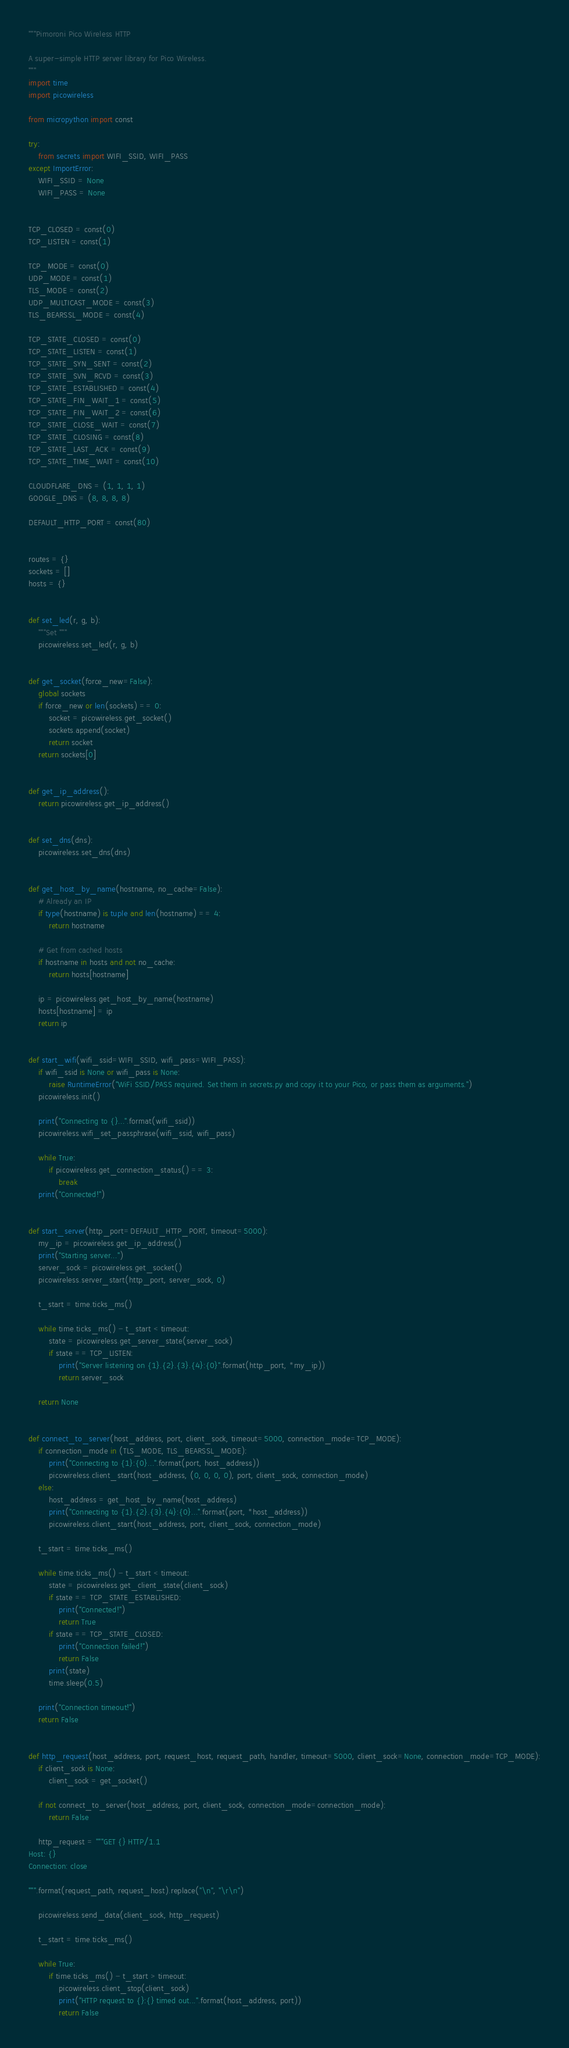Convert code to text. <code><loc_0><loc_0><loc_500><loc_500><_Python_>"""Pimoroni Pico Wireless HTTP

A super-simple HTTP server library for Pico Wireless.
"""
import time
import picowireless

from micropython import const

try:
    from secrets import WIFI_SSID, WIFI_PASS
except ImportError:
    WIFI_SSID = None
    WIFI_PASS = None


TCP_CLOSED = const(0)
TCP_LISTEN = const(1)

TCP_MODE = const(0)
UDP_MODE = const(1)
TLS_MODE = const(2)
UDP_MULTICAST_MODE = const(3)
TLS_BEARSSL_MODE = const(4)

TCP_STATE_CLOSED = const(0)
TCP_STATE_LISTEN = const(1)
TCP_STATE_SYN_SENT = const(2)
TCP_STATE_SVN_RCVD = const(3)
TCP_STATE_ESTABLISHED = const(4)
TCP_STATE_FIN_WAIT_1 = const(5)
TCP_STATE_FIN_WAIT_2 = const(6)
TCP_STATE_CLOSE_WAIT = const(7)
TCP_STATE_CLOSING = const(8)
TCP_STATE_LAST_ACK = const(9)
TCP_STATE_TIME_WAIT = const(10)

CLOUDFLARE_DNS = (1, 1, 1, 1)
GOOGLE_DNS = (8, 8, 8, 8)

DEFAULT_HTTP_PORT = const(80)


routes = {}
sockets = []
hosts = {}


def set_led(r, g, b):
    """Set """
    picowireless.set_led(r, g, b)


def get_socket(force_new=False):
    global sockets
    if force_new or len(sockets) == 0:
        socket = picowireless.get_socket()
        sockets.append(socket)
        return socket
    return sockets[0]


def get_ip_address():
    return picowireless.get_ip_address()


def set_dns(dns):
    picowireless.set_dns(dns)


def get_host_by_name(hostname, no_cache=False):
    # Already an IP
    if type(hostname) is tuple and len(hostname) == 4:
        return hostname

    # Get from cached hosts
    if hostname in hosts and not no_cache:
        return hosts[hostname]

    ip = picowireless.get_host_by_name(hostname)
    hosts[hostname] = ip
    return ip


def start_wifi(wifi_ssid=WIFI_SSID, wifi_pass=WIFI_PASS):
    if wifi_ssid is None or wifi_pass is None:
        raise RuntimeError("WiFi SSID/PASS required. Set them in secrets.py and copy it to your Pico, or pass them as arguments.")
    picowireless.init()

    print("Connecting to {}...".format(wifi_ssid))
    picowireless.wifi_set_passphrase(wifi_ssid, wifi_pass)

    while True:
        if picowireless.get_connection_status() == 3:
            break
    print("Connected!")


def start_server(http_port=DEFAULT_HTTP_PORT, timeout=5000):
    my_ip = picowireless.get_ip_address()
    print("Starting server...")
    server_sock = picowireless.get_socket()
    picowireless.server_start(http_port, server_sock, 0)

    t_start = time.ticks_ms()

    while time.ticks_ms() - t_start < timeout:
        state = picowireless.get_server_state(server_sock)
        if state == TCP_LISTEN:
            print("Server listening on {1}.{2}.{3}.{4}:{0}".format(http_port, *my_ip))
            return server_sock

    return None


def connect_to_server(host_address, port, client_sock, timeout=5000, connection_mode=TCP_MODE):
    if connection_mode in (TLS_MODE, TLS_BEARSSL_MODE):
        print("Connecting to {1}:{0}...".format(port, host_address))
        picowireless.client_start(host_address, (0, 0, 0, 0), port, client_sock, connection_mode)
    else:
        host_address = get_host_by_name(host_address)
        print("Connecting to {1}.{2}.{3}.{4}:{0}...".format(port, *host_address))
        picowireless.client_start(host_address, port, client_sock, connection_mode)

    t_start = time.ticks_ms()

    while time.ticks_ms() - t_start < timeout:
        state = picowireless.get_client_state(client_sock)
        if state == TCP_STATE_ESTABLISHED:
            print("Connected!")
            return True
        if state == TCP_STATE_CLOSED:
            print("Connection failed!")
            return False
        print(state)
        time.sleep(0.5)

    print("Connection timeout!")
    return False


def http_request(host_address, port, request_host, request_path, handler, timeout=5000, client_sock=None, connection_mode=TCP_MODE):
    if client_sock is None:
        client_sock = get_socket()

    if not connect_to_server(host_address, port, client_sock, connection_mode=connection_mode):
        return False

    http_request = """GET {} HTTP/1.1
Host: {}
Connection: close

""".format(request_path, request_host).replace("\n", "\r\n")

    picowireless.send_data(client_sock, http_request)

    t_start = time.ticks_ms()

    while True:
        if time.ticks_ms() - t_start > timeout:
            picowireless.client_stop(client_sock)
            print("HTTP request to {}:{} timed out...".format(host_address, port))
            return False
</code> 